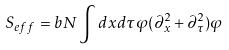Convert formula to latex. <formula><loc_0><loc_0><loc_500><loc_500>S _ { e f f } = b N \int d x d \tau \varphi ( \partial _ { x } ^ { 2 } + \partial _ { \tau } ^ { 2 } ) \varphi</formula> 